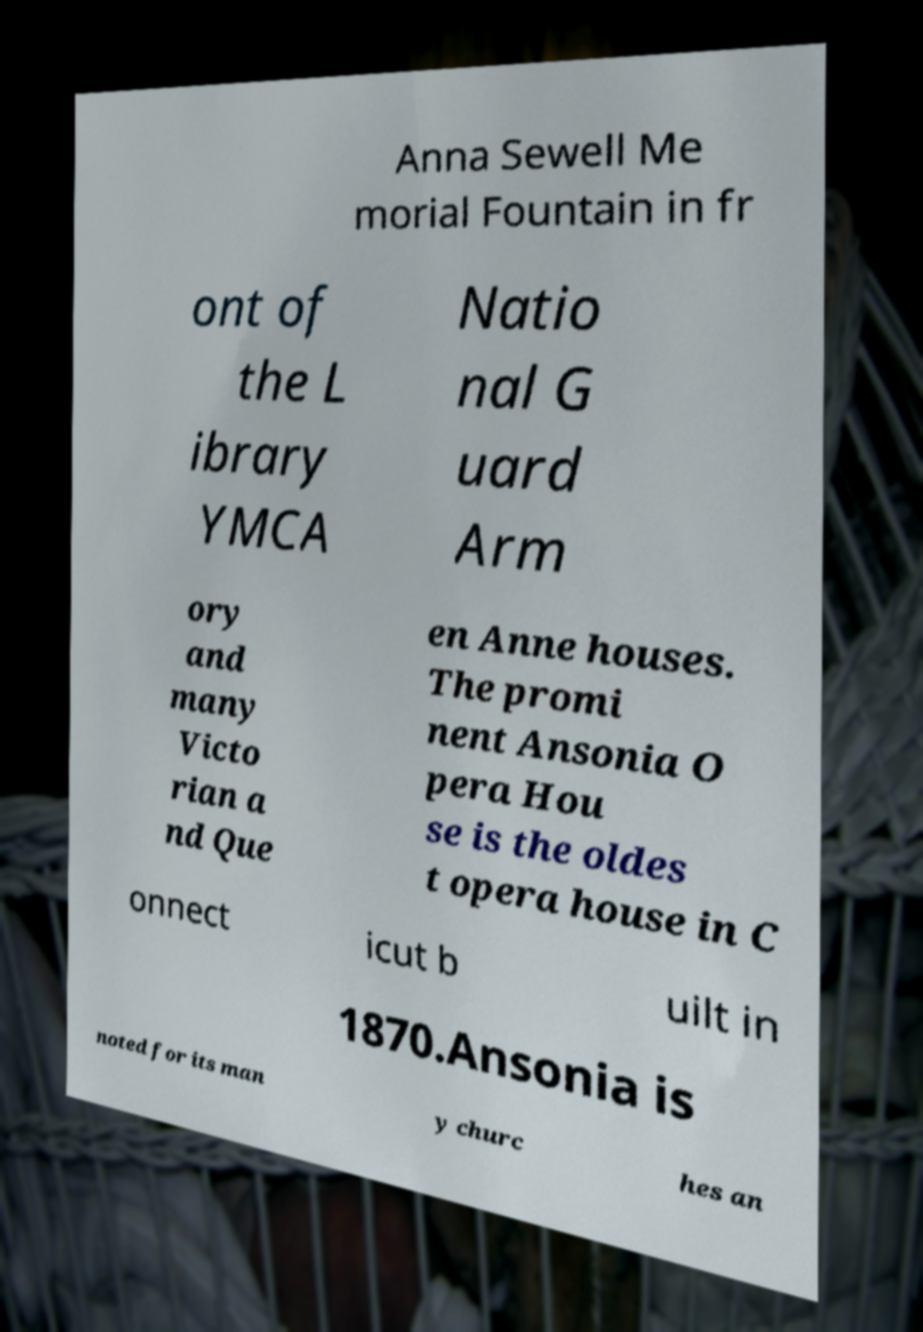Can you accurately transcribe the text from the provided image for me? Anna Sewell Me morial Fountain in fr ont of the L ibrary YMCA Natio nal G uard Arm ory and many Victo rian a nd Que en Anne houses. The promi nent Ansonia O pera Hou se is the oldes t opera house in C onnect icut b uilt in 1870.Ansonia is noted for its man y churc hes an 